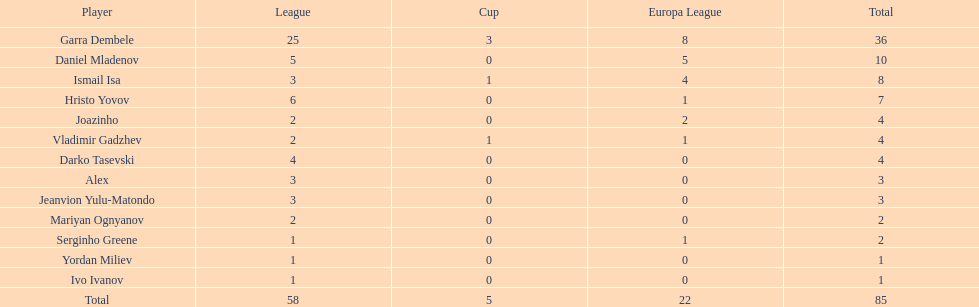How many participants achieved a total score of 4? 3. 